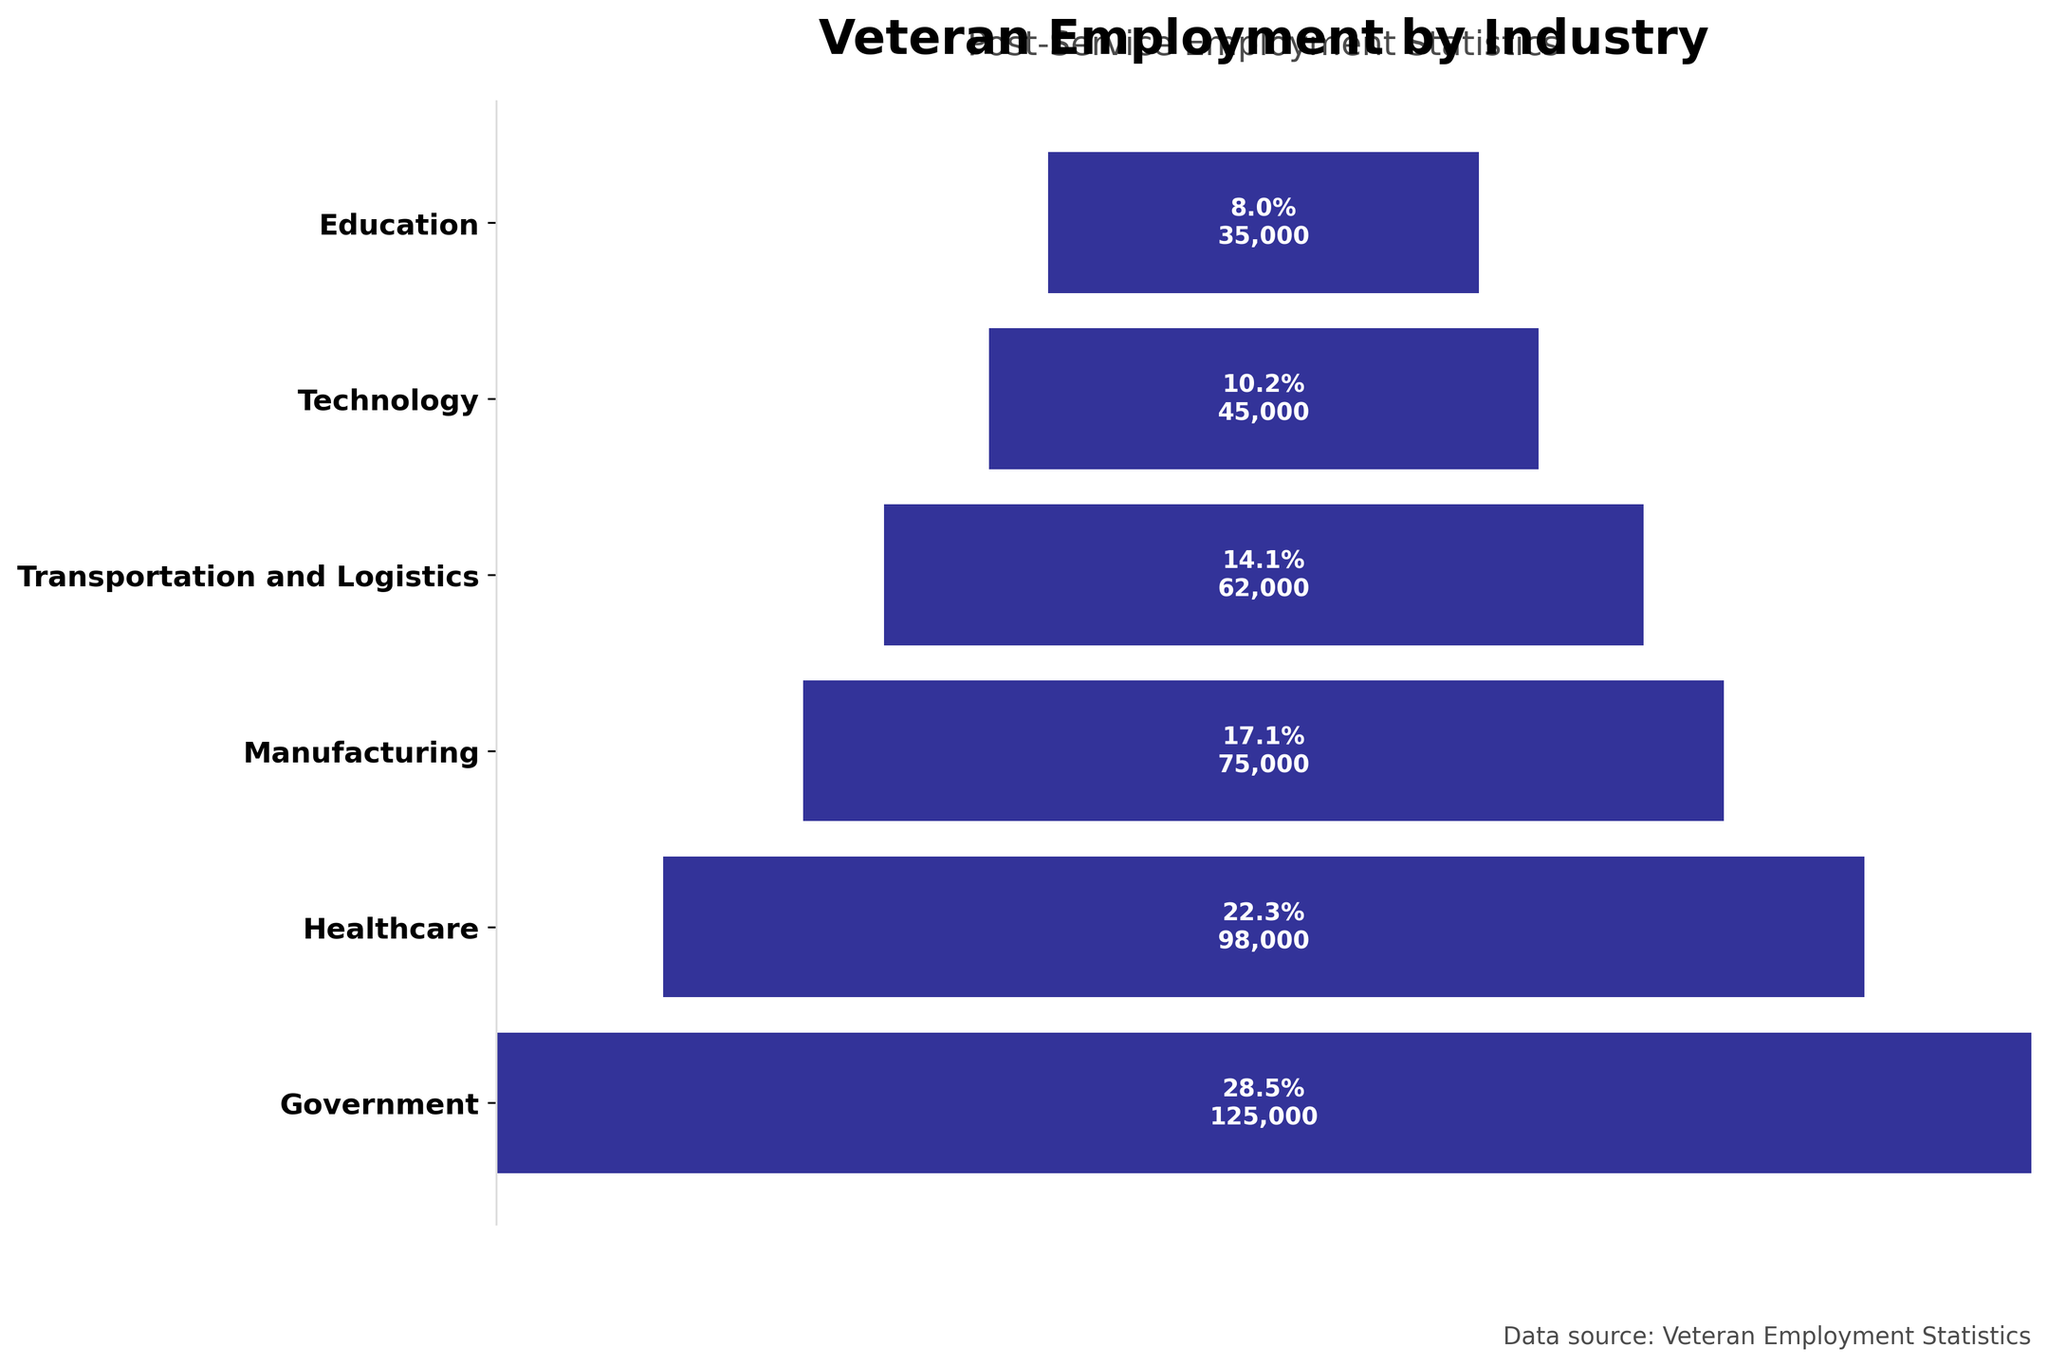How many industries are displayed in the chart? There are labels for each industry on the y-axis. By counting these, we find that six industries are displayed.
Answer: 6 Which industry employs the highest number of veterans? The bar corresponding to the Government industry is the longest and has the highest percentage value and employment count.
Answer: Government What percentage of veterans are employed in the Healthcare industry? The text within the Healthcare bar shows that 22.3% of veterans are employed in this industry.
Answer: 22.3% How many more veterans are employed in Manufacturing compared to Technology? The number of employed veterans in Manufacturing is 75,000 and in Technology is 45,000. Subtracting these gives 75,000 - 45,000 = 30,000.
Answer: 30,000 Which industry has the least veteran employment and how many veterans does it employ? The Education industry has the smallest bar and the lowest percentage and employment count, indicating it employs the fewest veterans. It employs 35,000 veterans.
Answer: Education, 35,000 What is the combined percentage of veteran employment in the Government and Transportation and Logistics industries? The percentages for Government and Transportation and Logistics are 28.5% and 14.1%. Adding these gives 28.5 + 14.1 = 42.6%.
Answer: 42.6% Are there more veterans employed in Healthcare or Manufacturing industries? The Healthcare bar reaches 22.3% while the Manufacturing bar reaches 17.1%, indicating more veterans are employed in Healthcare.
Answer: Healthcare What is the difference in percentage between the industry with the highest and the lowest veteran employment? The Government industry has the highest percentage (28.5%) and Education has the lowest (8%). Subtracting these gives 28.5 - 8 = 20.5%.
Answer: 20.5% If you were to create a pie chart from this data, which industries would take up over half of the chart combined? Combining the percentages of Government (28.5%) and Healthcare (22.3%) gives 28.5 + 22.3 = 50.8%, which is over half of the chart.
Answer: Government and Healthcare 